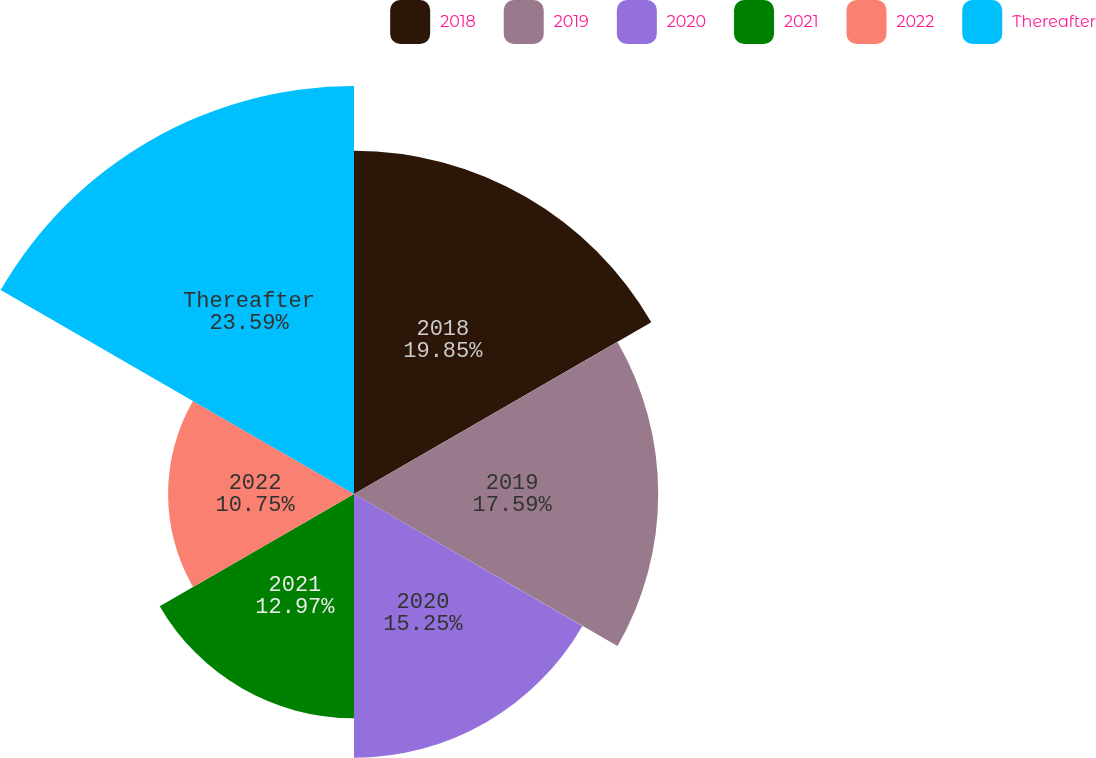Convert chart to OTSL. <chart><loc_0><loc_0><loc_500><loc_500><pie_chart><fcel>2018<fcel>2019<fcel>2020<fcel>2021<fcel>2022<fcel>Thereafter<nl><fcel>19.85%<fcel>17.59%<fcel>15.25%<fcel>12.97%<fcel>10.75%<fcel>23.59%<nl></chart> 